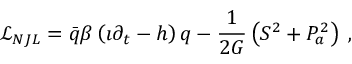Convert formula to latex. <formula><loc_0><loc_0><loc_500><loc_500>\mathcal { L } _ { N J L } = \bar { q } \beta \left ( \i \partial _ { t } - h \right ) q - { \frac { 1 } { 2 G } } \left ( S ^ { 2 } + P _ { a } ^ { 2 } \right ) \, ,</formula> 